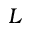<formula> <loc_0><loc_0><loc_500><loc_500>L</formula> 